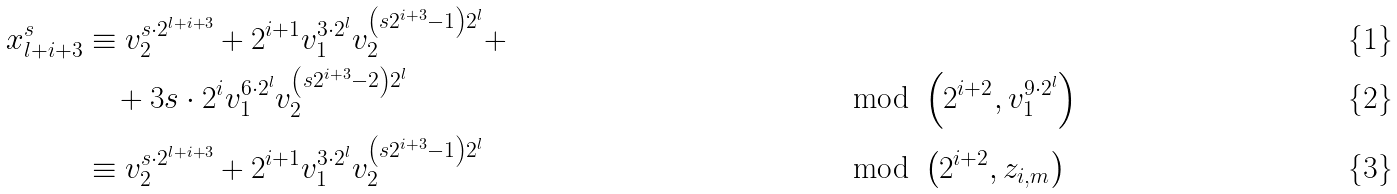<formula> <loc_0><loc_0><loc_500><loc_500>x _ { l + i + 3 } ^ { s } & \equiv v _ { 2 } ^ { s \cdot 2 ^ { l + i + 3 } } + 2 ^ { i + 1 } v _ { 1 } ^ { 3 \cdot 2 ^ { l } } v _ { 2 } ^ { \left ( s 2 ^ { i + 3 } - 1 \right ) 2 ^ { l } } + \\ & \quad + 3 s \cdot 2 ^ { i } v _ { 1 } ^ { 6 \cdot 2 ^ { l } } v _ { 2 } ^ { \left ( s 2 ^ { i + 3 } - 2 \right ) 2 ^ { l } } & & \mod \left ( 2 ^ { i + 2 } , v _ { 1 } ^ { 9 \cdot 2 ^ { l } } \right ) \\ & \equiv v _ { 2 } ^ { s \cdot 2 ^ { l + i + 3 } } + 2 ^ { i + 1 } v _ { 1 } ^ { 3 \cdot 2 ^ { l } } v _ { 2 } ^ { \left ( s 2 ^ { i + 3 } - 1 \right ) 2 ^ { l } } & & \mod \left ( 2 ^ { i + 2 } , z _ { i , m } \right )</formula> 